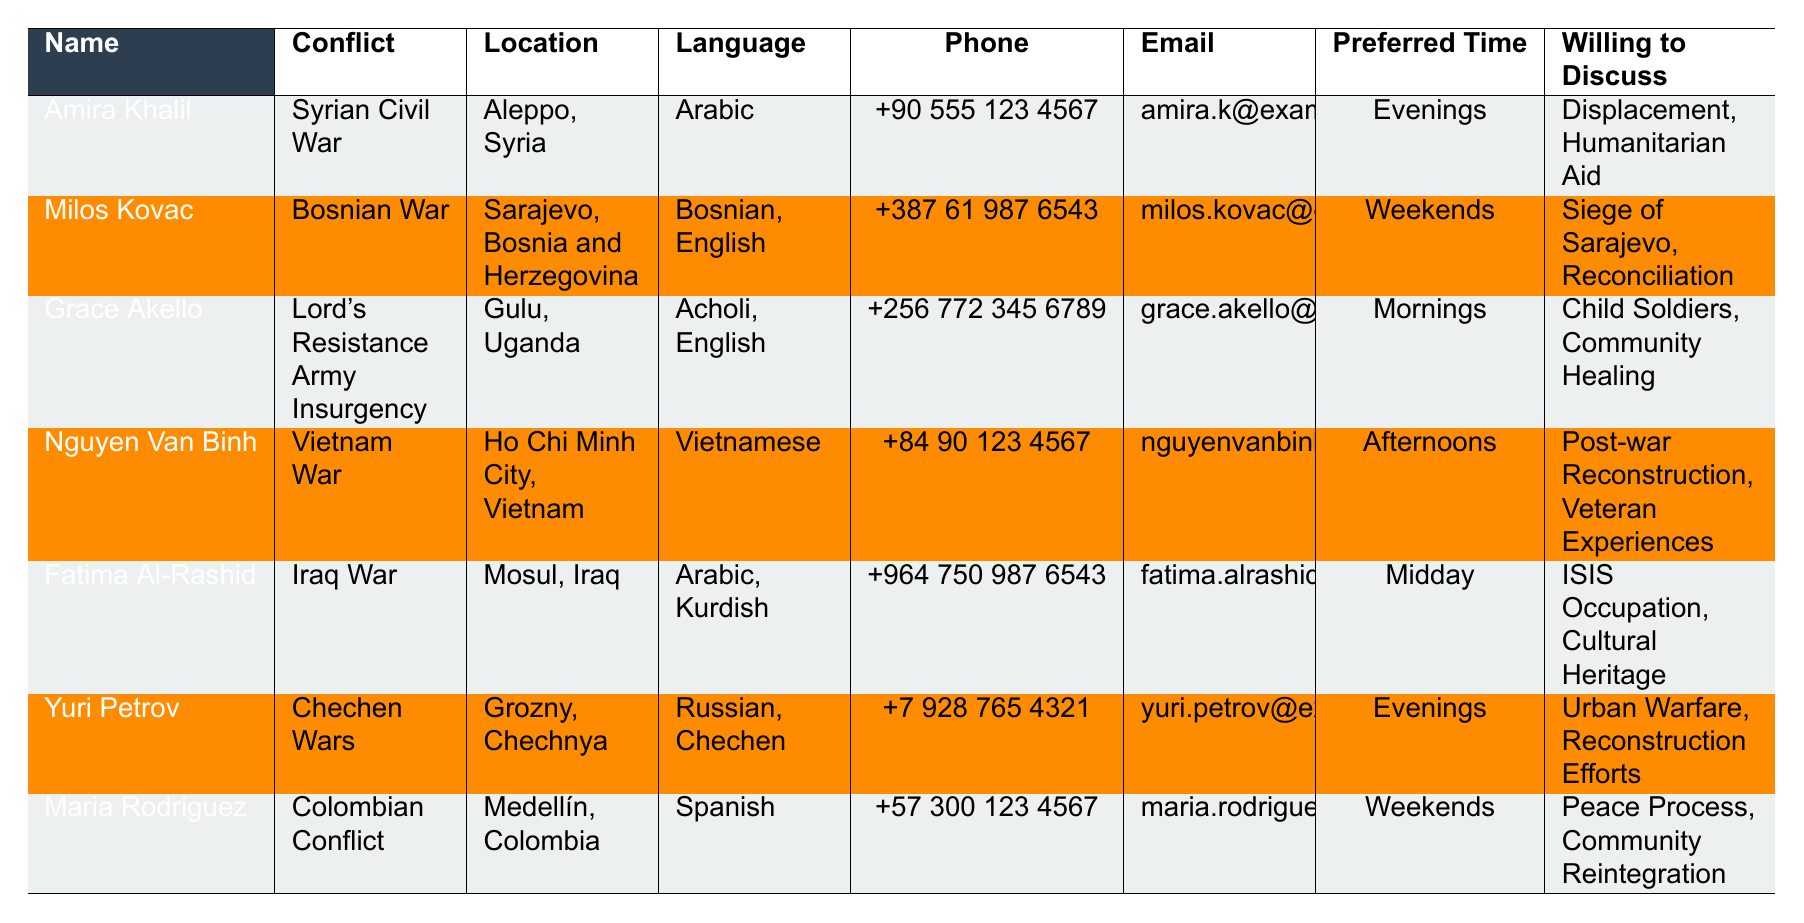What is the preferred interview time for Amira Khalil? The table shows that Amira Khalil's preferred interview time is listed under the "Preferred Interview Time" column. It indicates "Evenings."
Answer: Evenings What languages can Milos Kovac speak? Milos Kovac speaks both Bosnian and English, as mentioned in the "Language" column of the table.
Answer: Bosnian, English How many survivors are willing to discuss topics related to cultural heritage? The data shows that Fatima Al-Rashid is the only survivor who is willing to discuss "Cultural Heritage". Hence, there is 1 survivor.
Answer: 1 Which conflict does Grace Akello relate to? The "Conflict" column for Grace Akello indicates "Lord's Resistance Army Insurgency."
Answer: Lord's Resistance Army Insurgency What is the phone number of Yuri Petrov? The phone number is given in the "Phone" column corresponding to Yuri Petrov. It is "+7 928 765 4321."
Answer: +7 928 765 4321 Are there any survivors who prefer to be interviewed on weekends? The table indicates that both Milos Kovac and Maria Rodriguez prefer weekends for interviews, hence the answer is yes.
Answer: Yes What are the two topics that Nguyen Van Binh is willing to discuss? The table specifies the topics under the "Willing to Discuss" column for Nguyen Van Binh as "Post-war Reconstruction, Veteran Experiences."
Answer: Post-war Reconstruction, Veteran Experiences How many survivors can speak Arabic? Amira Khalil and Fatima Al-Rashid both speak Arabic, leading to a total of 2 survivors.
Answer: 2 What is the average number of languages spoken by the survivors listed in the table? The survivors speak a total of 10 languages collectively (1: Arabic, 2: Bosnian, English, 2: Acholi, English, 1: Vietnamese, 2: Arabic, Kurdish, 2: Russian, Chechen, 1: Spanish). The total number of survivors is 7. Thus, the average is 10/7, approximately 1.43.
Answer: Approximately 1.43 Who are the survivors willing to discuss the topic of child soldiers? The table shows that Grace Akello is the only survivor willing to discuss "Child Soldiers."
Answer: Grace Akello What is the location of the survivor who speaks Spanish? The table reveals that Maria Rodriguez is the survivor who speaks Spanish, and she is located in Medellín, Colombia.
Answer: Medellín, Colombia 